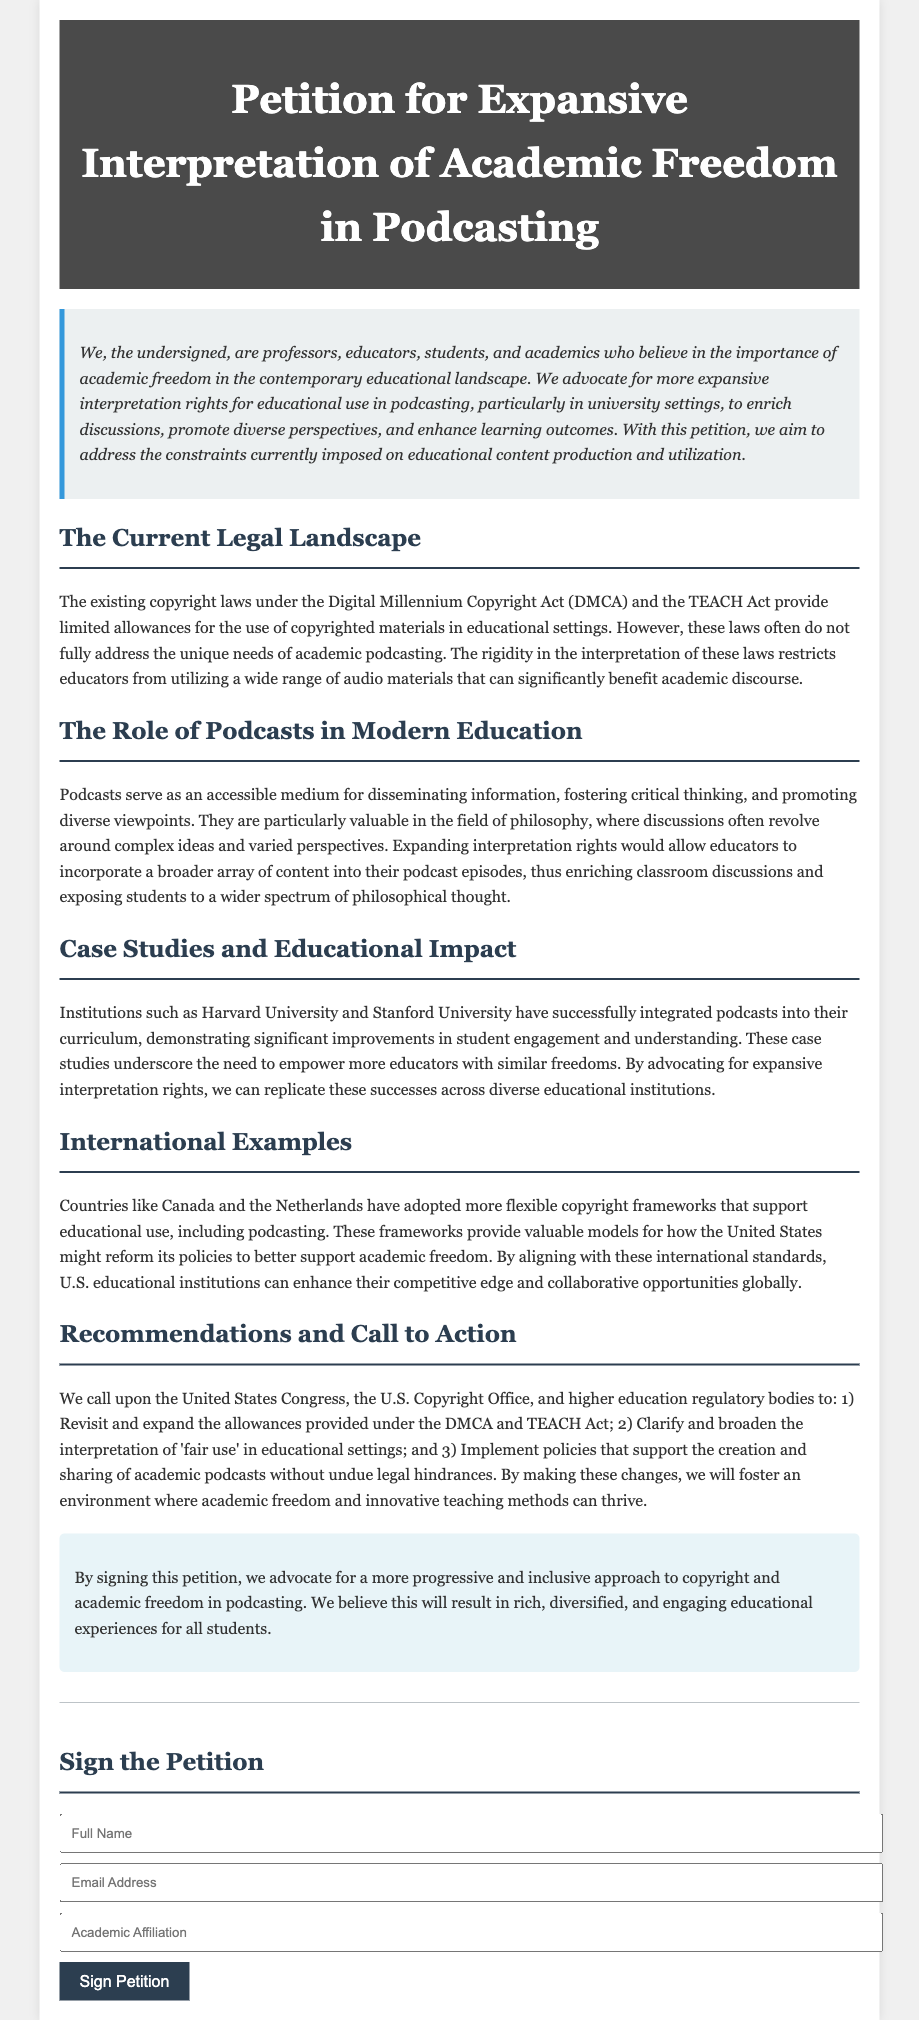What is the title of the petition? The title of the petition is provided in the document's header section.
Answer: Petition for Expansive Interpretation of Academic Freedom in Podcasting Who are the main advocates mentioned in the petition? The petition states the advocates are professors, educators, students, and academics.
Answer: professors, educators, students, and academics What law is mentioned regarding existing copyright restrictions? The document cites the Digital Millennium Copyright Act (DMCA) as a significant law affecting copyright restrictions.
Answer: Digital Millennium Copyright Act (DMCA) What universities are referenced as having successfully integrated podcasts? The petition mentions two prominent universities noted for podcast integration in their curriculum.
Answer: Harvard University and Stanford University What are the three recommendations given in the petition? The document lists three calls to action aimed at U.S. copyright reform, which are outlined in the recommendations section.
Answer: Revisit and expand the allowances provided under the DMCA and TEACH Act; Clarify and broaden the interpretation of 'fair use' in educational settings; Implement policies that support the creation and sharing of academic podcasts Which countries are mentioned as having flexible copyright frameworks? The petition refers to two countries that have adopted more flexible copyright frameworks supportive of educational use.
Answer: Canada and the Netherlands What is the main purpose of this petition? The purpose is summarized in the initial section and focuses on academic freedom in podcasting specifically.
Answer: To advocate for more expansive interpretation rights for educational use in podcasting What benefit does podcasting provide in education according to the document? The document claims podcasting offers significant benefits to educational discourse and learning outcomes.
Answer: Disseminating information, fostering critical thinking, and promoting diverse viewpoints 